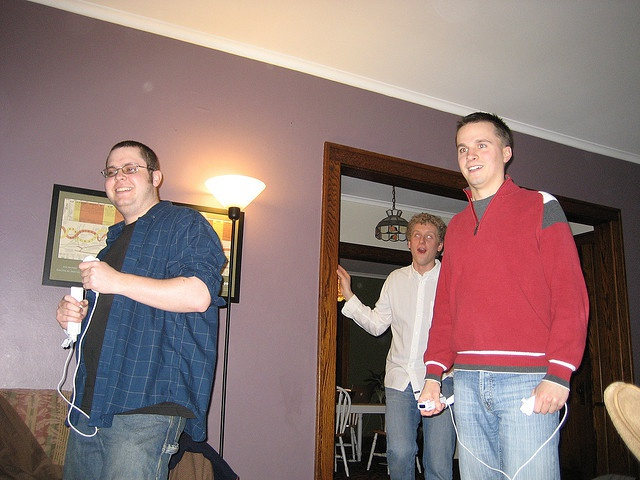Describe the objects in this image and their specific colors. I can see people in black, blue, gray, and lightgray tones, people in black, brown, lightgray, lightblue, and darkgray tones, people in black, lightgray, and gray tones, couch in black, gray, and maroon tones, and chair in black, darkgray, gray, and maroon tones in this image. 